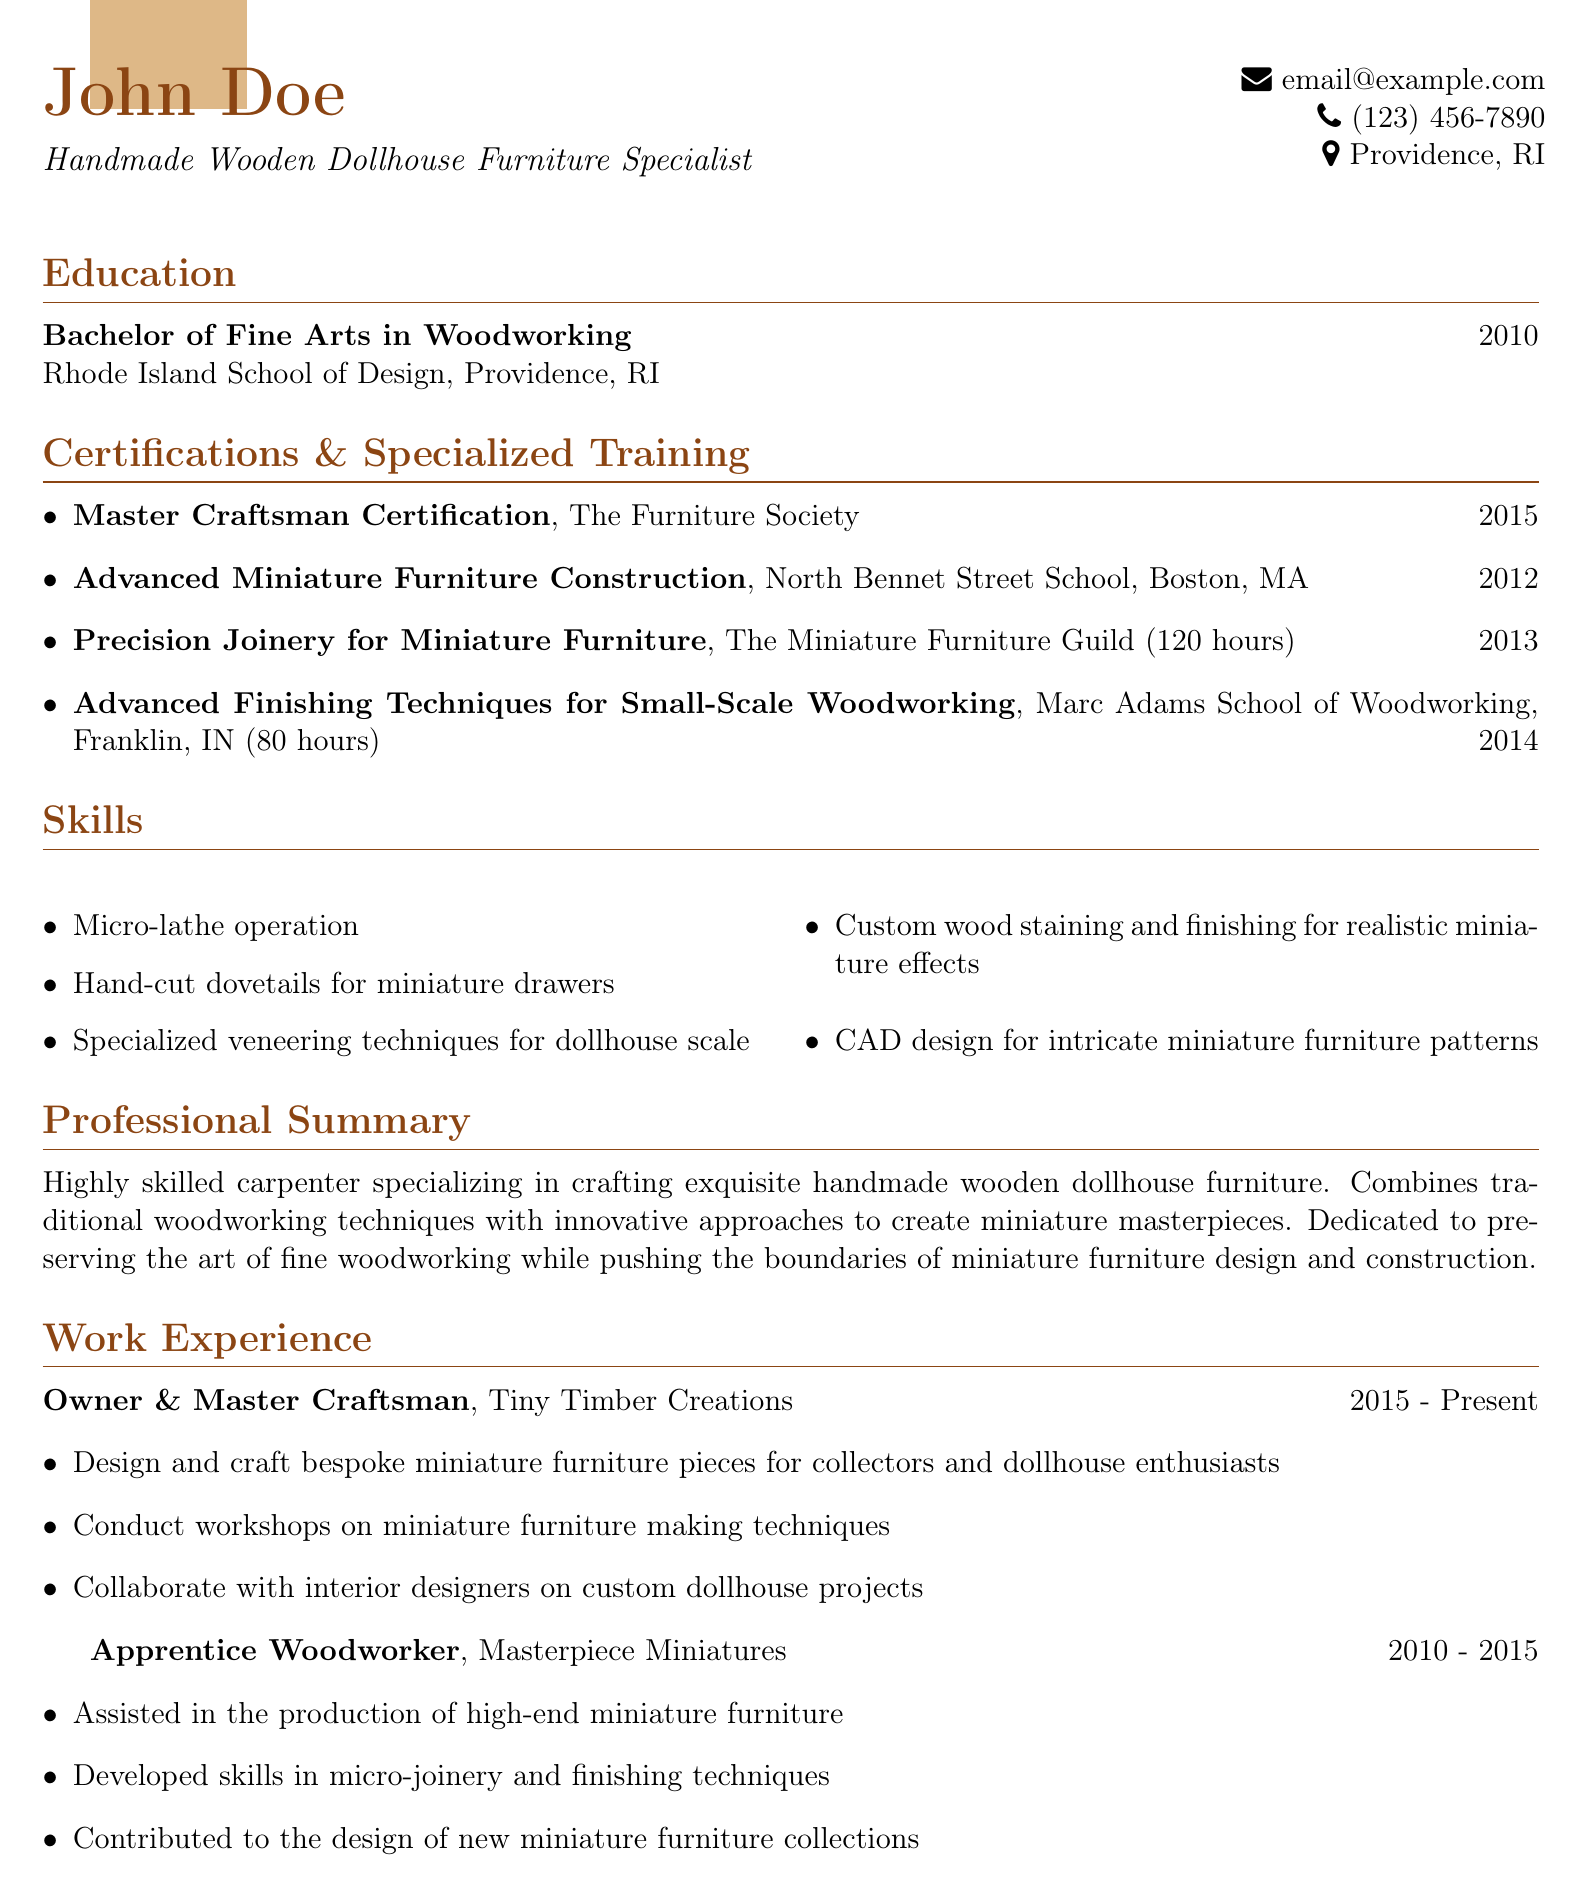What degree did John Doe earn? The document states that John Doe earned a Bachelor of Fine Arts in Woodworking.
Answer: Bachelor of Fine Arts in Woodworking Where did John Doe study? According to the document, John Doe studied at the Rhode Island School of Design.
Answer: Rhode Island School of Design What year did John Doe receive the Master Craftsman Certification? The document indicates that the Master Craftsman Certification was received in 2015.
Answer: 2015 Which course focused on finishing techniques? The document lists the course "Advanced Finishing Techniques for Small-Scale Woodworking" as relevant to finishing techniques.
Answer: Advanced Finishing Techniques for Small-Scale Woodworking How many hours did the Precision Joinery course last? The document states that the Precision Joinery for Miniature Furniture course lasted 120 hours.
Answer: 120 hours What is the main occupation of John Doe? The document indicates that John Doe is a Handmade Wooden Dollhouse Furniture Specialist.
Answer: Handmade Wooden Dollhouse Furniture Specialist What type of skills does John Doe possess? The document lists specific skills including micro-lathe operation, hand-cut dovetails, and more related to woodworking.
Answer: Micro-lathe operation, hand-cut dovetails, specialized veneering techniques In which city is John Doe located? The document specifies that John Doe is located in Providence, RI.
Answer: Providence, RI Who issued the certification for Advanced Miniature Furniture Construction? The document specifies that the North Bennet Street School issued this certification.
Answer: North Bennet Street School 